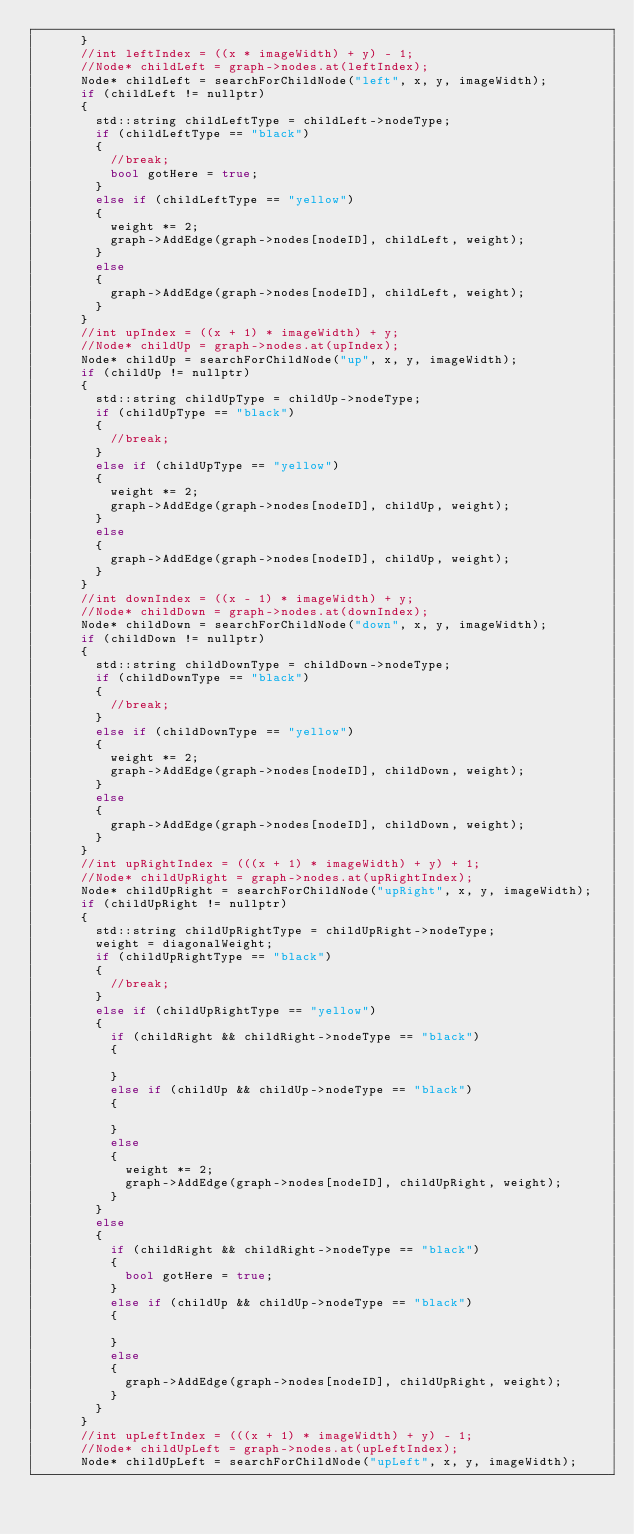Convert code to text. <code><loc_0><loc_0><loc_500><loc_500><_C++_>			}
			//int leftIndex = ((x * imageWidth) + y) - 1;
			//Node* childLeft = graph->nodes.at(leftIndex);
			Node* childLeft = searchForChildNode("left", x, y, imageWidth);
			if (childLeft != nullptr)
			{
				std::string childLeftType = childLeft->nodeType;
				if (childLeftType == "black")
				{
					//break;
					bool gotHere = true;
				}
				else if (childLeftType == "yellow")
				{
					weight *= 2;
					graph->AddEdge(graph->nodes[nodeID], childLeft, weight);
				}
				else
				{
					graph->AddEdge(graph->nodes[nodeID], childLeft, weight);
				}
			}
			//int upIndex = ((x + 1) * imageWidth) + y;
			//Node* childUp = graph->nodes.at(upIndex);
			Node* childUp = searchForChildNode("up", x, y, imageWidth);
			if (childUp != nullptr)
			{
				std::string childUpType = childUp->nodeType;
				if (childUpType == "black")
				{
					//break;
				}
				else if (childUpType == "yellow")
				{
					weight *= 2;
					graph->AddEdge(graph->nodes[nodeID], childUp, weight);
				}
				else
				{
					graph->AddEdge(graph->nodes[nodeID], childUp, weight);
				}
			}
			//int downIndex = ((x - 1) * imageWidth) + y;
			//Node* childDown = graph->nodes.at(downIndex);
			Node* childDown = searchForChildNode("down", x, y, imageWidth);
			if (childDown != nullptr)
			{
				std::string childDownType = childDown->nodeType;
				if (childDownType == "black")
				{
					//break;
				}
				else if (childDownType == "yellow")
				{
					weight *= 2;
					graph->AddEdge(graph->nodes[nodeID], childDown, weight);
				}
				else
				{
					graph->AddEdge(graph->nodes[nodeID], childDown, weight);
				}
			}
			//int upRightIndex = (((x + 1) * imageWidth) + y) + 1;
			//Node* childUpRight = graph->nodes.at(upRightIndex);
			Node* childUpRight = searchForChildNode("upRight", x, y, imageWidth);
			if (childUpRight != nullptr)
			{
				std::string childUpRightType = childUpRight->nodeType;
				weight = diagonalWeight;
				if (childUpRightType == "black")
				{
					//break;
				}
				else if (childUpRightType == "yellow")
				{
					if (childRight && childRight->nodeType == "black")
					{

					}
					else if (childUp && childUp->nodeType == "black")
					{

					}
					else
					{
						weight *= 2;
						graph->AddEdge(graph->nodes[nodeID], childUpRight, weight);
					}
				}
				else
				{
					if (childRight && childRight->nodeType == "black")
					{
						bool gotHere = true;
					}
					else if (childUp && childUp->nodeType == "black")
					{

					}
					else
					{
						graph->AddEdge(graph->nodes[nodeID], childUpRight, weight);
					}
				}
			}
			//int upLeftIndex = (((x + 1) * imageWidth) + y) - 1;
			//Node* childUpLeft = graph->nodes.at(upLeftIndex);
			Node* childUpLeft = searchForChildNode("upLeft", x, y, imageWidth);</code> 